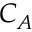<formula> <loc_0><loc_0><loc_500><loc_500>C _ { A }</formula> 